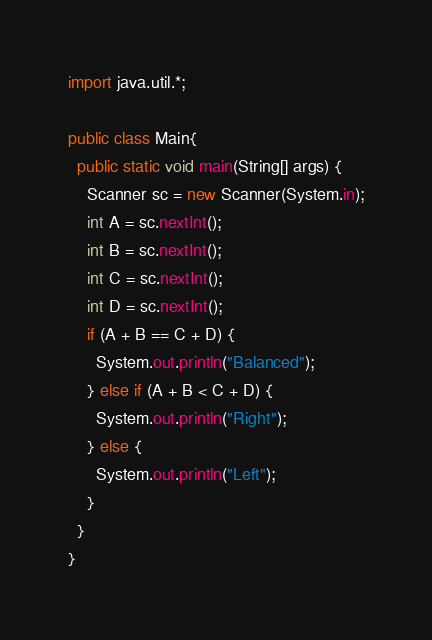<code> <loc_0><loc_0><loc_500><loc_500><_Java_>import java.util.*;

public class Main{
  public static void main(String[] args) {
    Scanner sc = new Scanner(System.in);
    int A = sc.nextInt();
    int B = sc.nextInt();
    int C = sc.nextInt();
    int D = sc.nextInt();
    if (A + B == C + D) {
      System.out.println("Balanced");
    } else if (A + B < C + D) {
      System.out.println("Right");
    } else {
      System.out.println("Left");
    }
  }
}</code> 